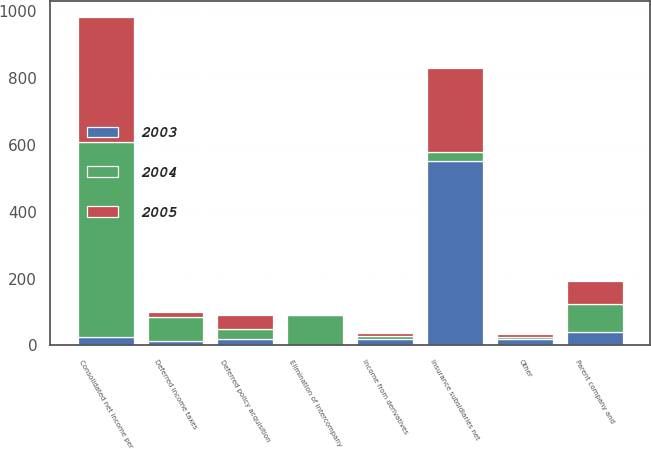Convert chart. <chart><loc_0><loc_0><loc_500><loc_500><stacked_bar_chart><ecel><fcel>Consolidated net income per<fcel>Deferred policy acquisition<fcel>Deferred income taxes<fcel>Income from derivatives<fcel>Elimination of intercompany<fcel>Parent company and<fcel>Other<fcel>Insurance subsidiaries net<nl><fcel>2003<fcel>24.5<fcel>19<fcel>13<fcel>19<fcel>2<fcel>41<fcel>19<fcel>553<nl><fcel>2004<fcel>584<fcel>30<fcel>73<fcel>10<fcel>88<fcel>84<fcel>6<fcel>24.5<nl><fcel>2005<fcel>374<fcel>42<fcel>13<fcel>9<fcel>0<fcel>67<fcel>10<fcel>253<nl></chart> 